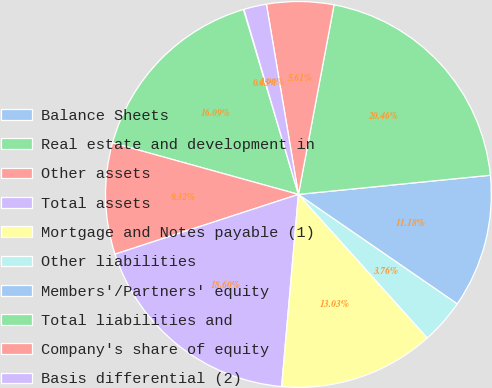Convert chart to OTSL. <chart><loc_0><loc_0><loc_500><loc_500><pie_chart><fcel>Balance Sheets<fcel>Real estate and development in<fcel>Other assets<fcel>Total assets<fcel>Mortgage and Notes payable (1)<fcel>Other liabilities<fcel>Members'/Partners' equity<fcel>Total liabilities and<fcel>Company's share of equity<fcel>Basis differential (2)<nl><fcel>0.05%<fcel>16.09%<fcel>9.32%<fcel>18.6%<fcel>13.03%<fcel>3.76%<fcel>11.18%<fcel>20.46%<fcel>5.61%<fcel>1.9%<nl></chart> 